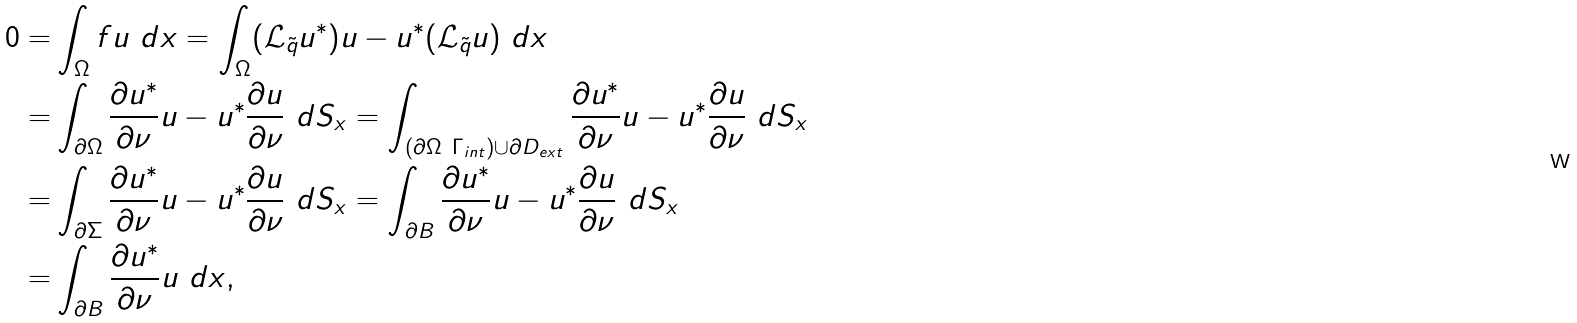<formula> <loc_0><loc_0><loc_500><loc_500>0 = & \int _ { \Omega } f u \ d x = \int _ { \Omega } ( \mathcal { L } _ { \tilde { q } } u ^ { * } ) u - u ^ { * } ( \mathcal { L } _ { \tilde { q } } u ) \ d x \\ = & \int _ { \partial \Omega } \frac { \partial u ^ { * } } { \partial \nu } u - u ^ { * } \frac { \partial u } { \partial \nu } \ d S _ { x } = \int _ { ( \partial \Omega \ \Gamma _ { i n t } ) \cup \partial D _ { e x t } } \frac { \partial u ^ { * } } { \partial \nu } u - u ^ { * } \frac { \partial u } { \partial \nu } \ d S _ { x } \\ = & \int _ { \partial \Sigma } \frac { \partial u ^ { * } } { \partial \nu } u - u ^ { * } \frac { \partial u } { \partial \nu } \ d S _ { x } = \int _ { \partial B } \frac { \partial u ^ { * } } { \partial \nu } u - u ^ { * } \frac { \partial u } { \partial \nu } \ d S _ { x } \\ = & \int _ { \partial B } \frac { \partial u ^ { * } } { \partial \nu } u \ d x ,</formula> 